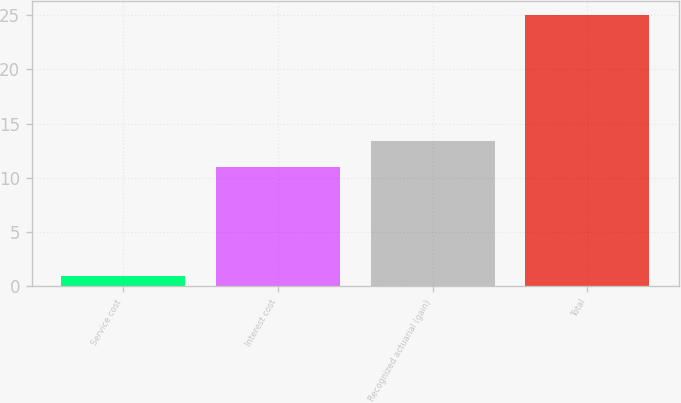Convert chart to OTSL. <chart><loc_0><loc_0><loc_500><loc_500><bar_chart><fcel>Service cost<fcel>Interest cost<fcel>Recognized actuarial (gain)<fcel>Total<nl><fcel>1<fcel>11<fcel>13.4<fcel>25<nl></chart> 